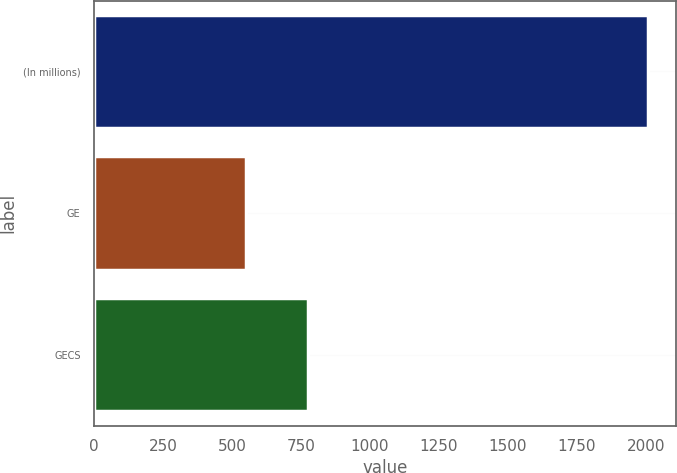Convert chart. <chart><loc_0><loc_0><loc_500><loc_500><bar_chart><fcel>(In millions)<fcel>GE<fcel>GECS<nl><fcel>2009<fcel>550<fcel>774<nl></chart> 